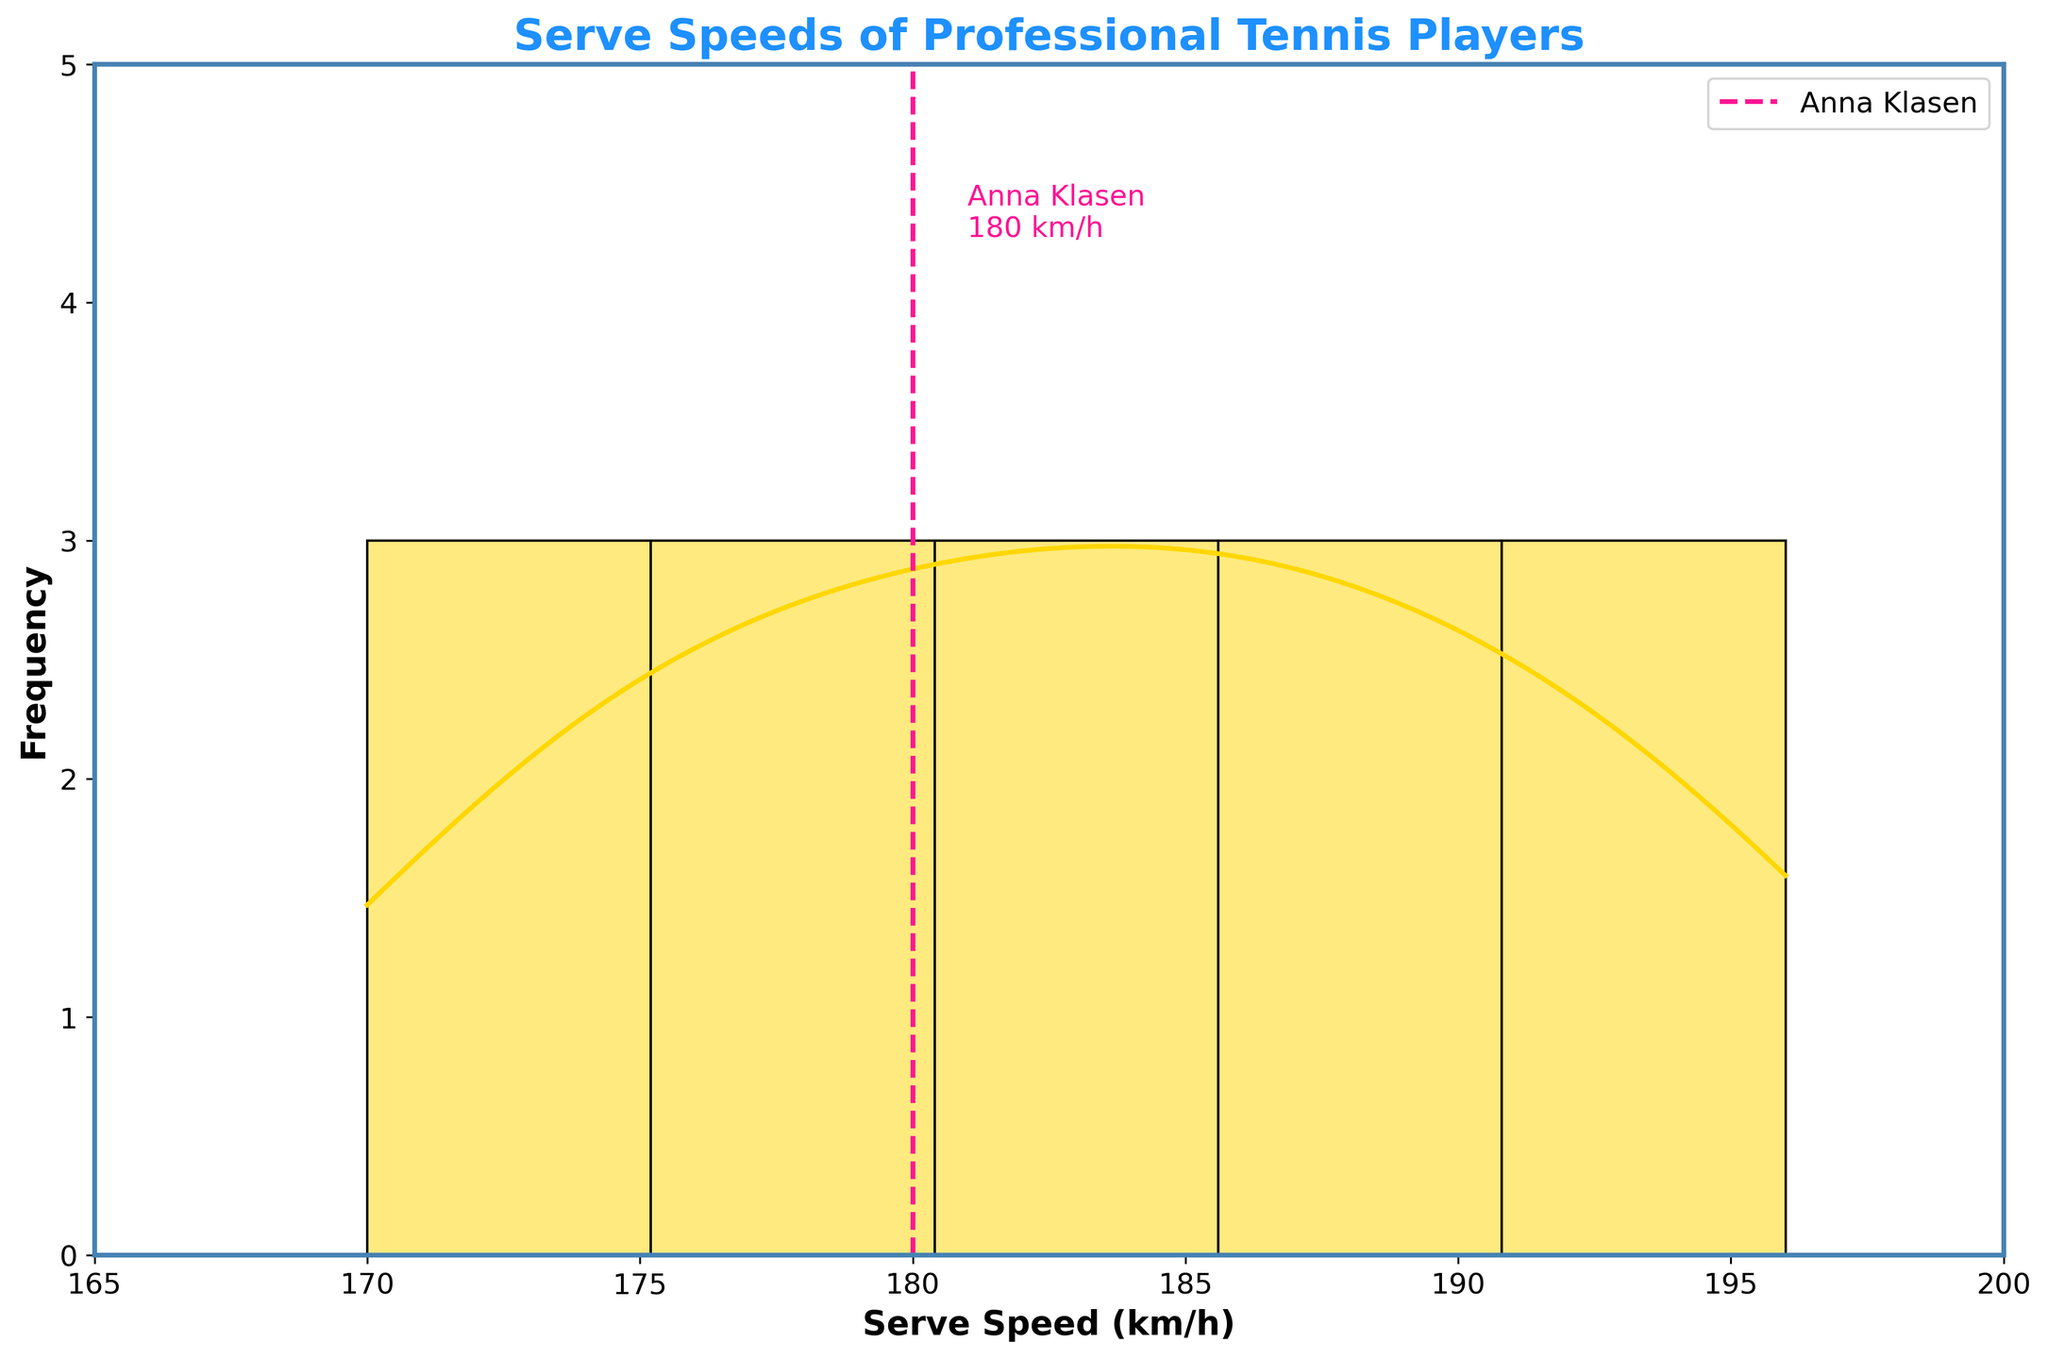What is the title of the figure? The title of the figure is typically placed at the top of the chart and summarizes the data represented.
Answer: Serve Speeds of Professional Tennis Players What is the serve speed of Anna Klasen, and how is it represented in the figure? The serve speed of Anna Klasen is represented by a vertical dashed line on the histogram. The speed value and her name are also labeled next to this line.
Answer: 180 km/h How many players have serve speeds between 185 km/h and 195 km/h? From the histogram bars, identify the bars that fall within the 185 - 195 km/h range and count the number of players represented by these bars.
Answer: 5 players What is the most common serve speed range among the players, according to the histogram? The most common range is indicated by the tallest bar(s) on the histogram.
Answer: 180-185 km/h What does the KDE (density curve) indicate about the serve speeds? The KDE (Kernel Density Estimate) curve provides a smoothed approximation of the data distribution, indicating the probability density of serve speeds. The peak of the KDE curve shows where the serve speeds are most concentrated.
Answer: Shows distribution and concentration How does Anna Klasen's serve speed compare to the average serve speed of the players? Calculate the average serve speed by summing all the serve speeds and dividing by the number of players. Compare this value to Anna Klasen's serve speed. Anna Klasen's speed (180 km/h) is lower than the average speed.
Answer: Lower than average Which player has the fastest serve speed, and how is this value represented in the figure? Identify the player with the highest serve speed from the data and locate the corresponding bar on the histogram. Note the value and the player's name.
Answer: Sabine Lisicki (196 km/h) What is the range of serve speeds displayed in the histogram? The range is determined by the smallest and largest serve speeds shown on the x-axis of the histogram, spanning from the lowest to the highest values shown in the histogram.
Answer: 165-200 km/h How is the serve speed of Anna Klasen visually differentiated from the other serve speeds in the figure? Anna Klasen's serve speed is indicated by a distinct vertical dashed line and labeled with her name and speed value, differing from the other bars.
Answer: Vertical dashed line and label What is the color of the histogram bars and the KDE curve? Identify the colors used for the histogram bars and the density curve from the visual representation in the figure.
Answer: Histogram bars: gold, KDE curve: red 